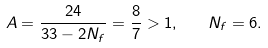Convert formula to latex. <formula><loc_0><loc_0><loc_500><loc_500>A = \frac { 2 4 } { 3 3 - 2 N _ { f } } = \frac { 8 } { 7 } > 1 , \quad N _ { f } = 6 .</formula> 